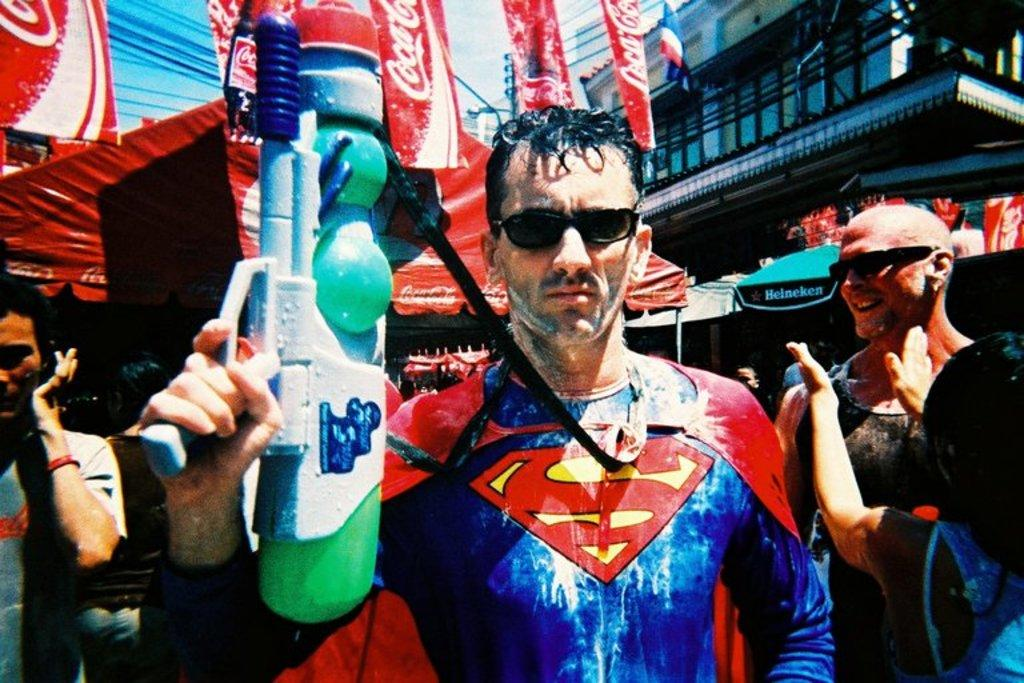What type of structures can be seen in the image? There are buildings in the image. What objects are present to provide shade in the image? There are parasols in the image. What are the people in the image doing? There are people standing on the road in the image. What type of dinner is being served in the image? There is no dinner present in the image; it only features buildings, parasols, and people standing on the road. 